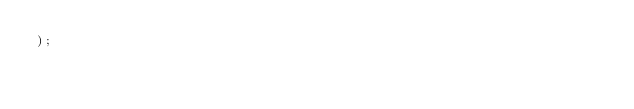<code> <loc_0><loc_0><loc_500><loc_500><_SQL_>);
</code> 